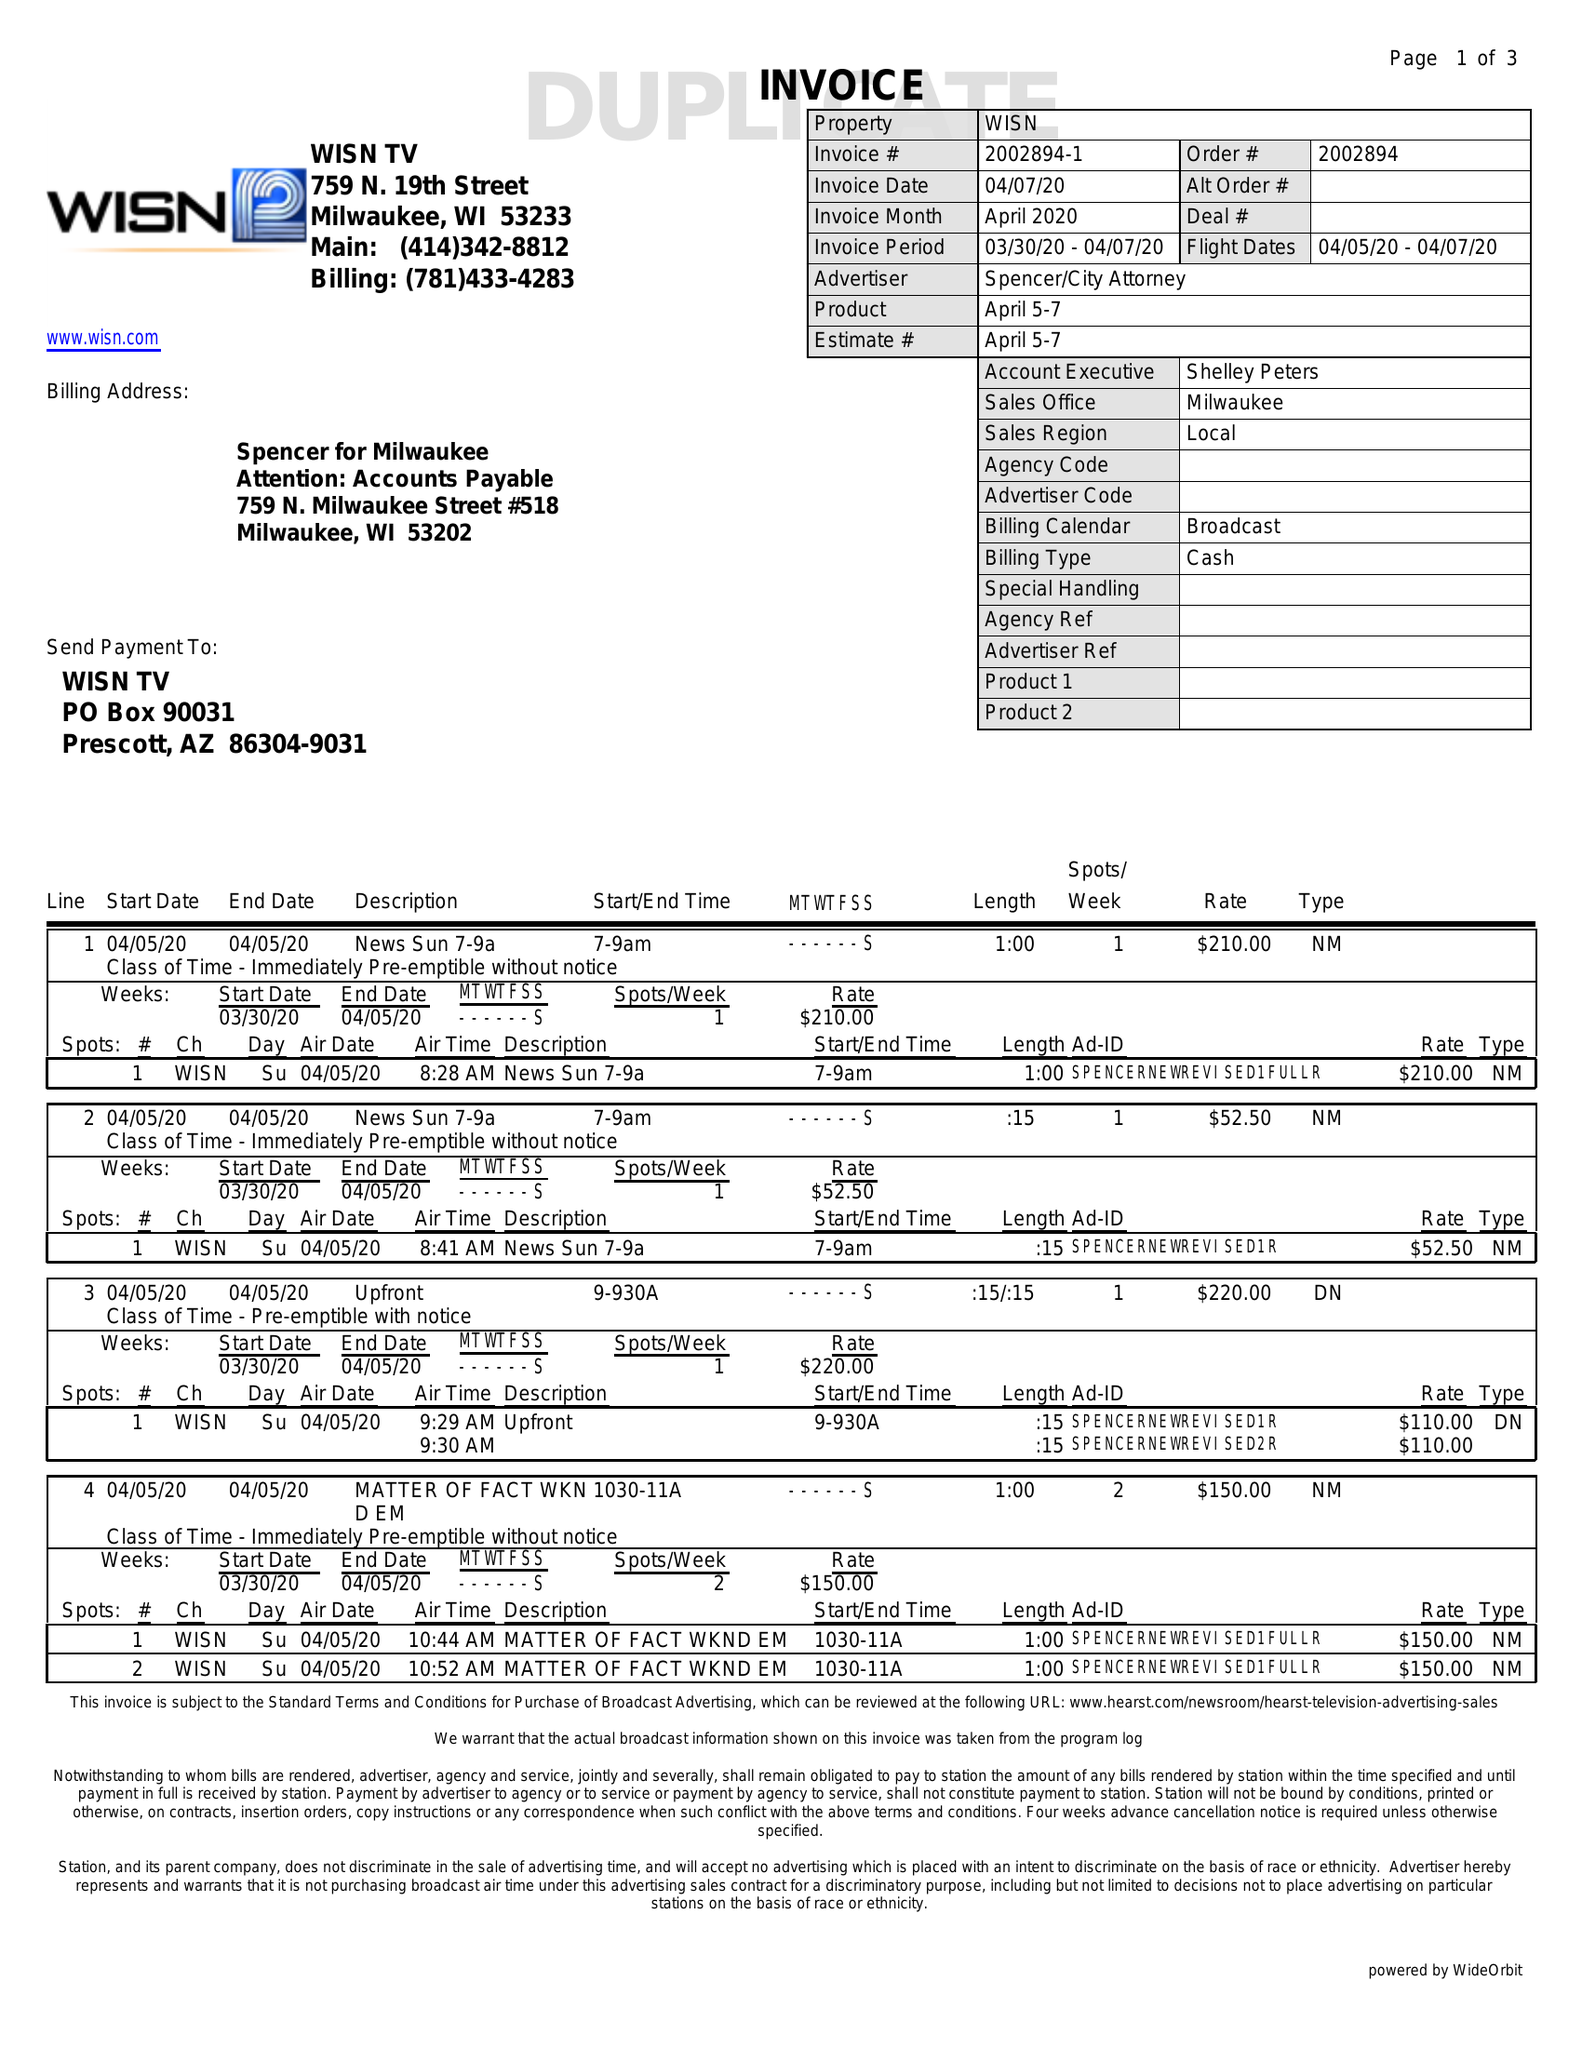What is the value for the flight_from?
Answer the question using a single word or phrase. 04/05/20 